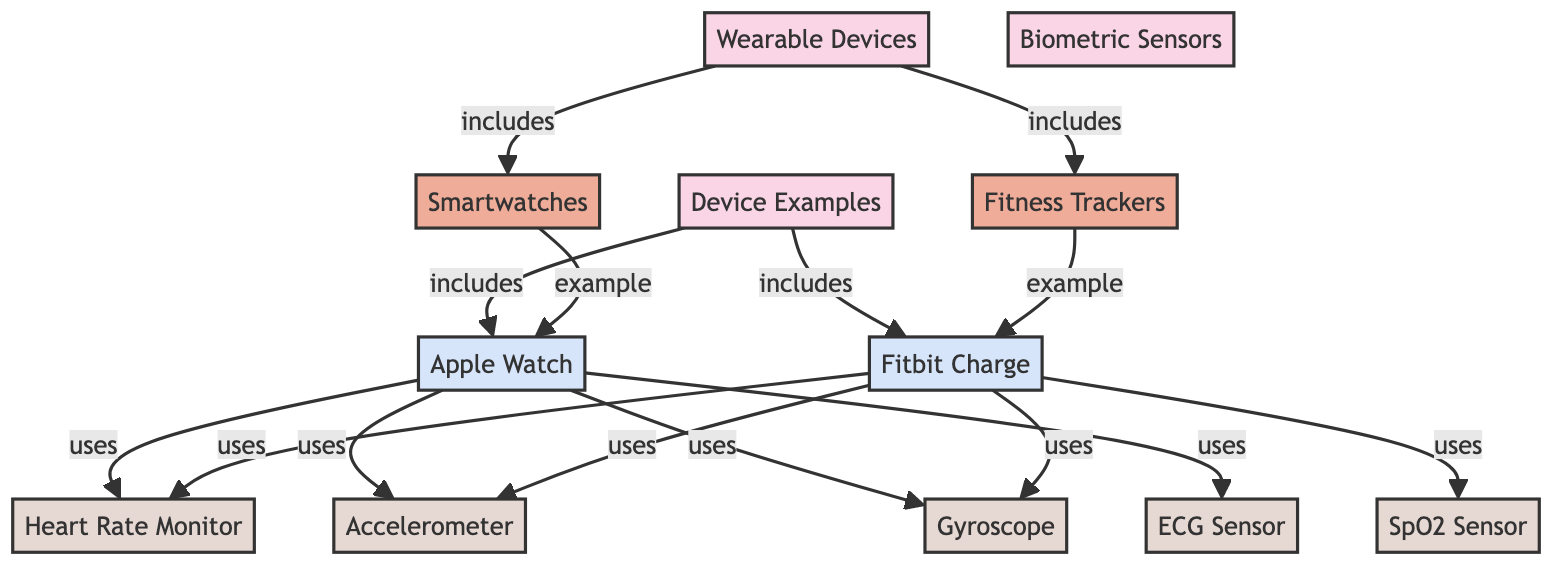What subcategories fall under wearable devices? The diagram shows that the subcategories of wearable devices include smartwatches and fitness trackers, which are directly connected to the main category of wearable devices.
Answer: smartwatches, fitness trackers Which device is an example of a smartwatch? The diagram illustrates that the Apple Watch is categorized as an example under the smartwatch subcategory, indicated by its direct connection to that node.
Answer: Apple Watch How many types of biometric sensors are represented in the diagram? By examining the biometric sensors section, we can see that there are five different types listed, including heart rate monitor, accelerometer, gyroscope, SpO2 sensor, and ECG sensor.
Answer: five What sensor is used by both Apple Watch and Fitbit Charge? Both devices use the heart rate monitor, which is linked to both the Apple Watch and Fitbit Charge nodes in the diagram, highlighting its commonality between these two devices.
Answer: heart rate monitor Which device utilizes the SpO2 sensor? The diagram shows that the Fitbit Charge is the only device listed that utilizes the SpO2 sensor, as it directly connects only to the Fitbit Charge node and not to the Apple Watch.
Answer: Fitbit Charge How many total sensors are listed in the diagram? The diagram outlines a total of five different sensors, signifying their presence in the biometric sensors category.
Answer: five What relationship exists between smartwatches and the sensors they use? Smartwatches are shown to use four different sensors: heart rate monitor, accelerometer, gyroscope, and ECG sensor, indicating a multiple connection between these categories.
Answer: uses Which wearable device uses the most sensors according to the diagram? Analyzing the connections, it becomes clear that the Apple Watch employs four sensors, while the Fitbit Charge employs three, making the Apple Watch the device that utilizes the most sensors.
Answer: Apple Watch What is the primary category of health devices represented in the diagram? The main category presented in the diagram that encompasses all related wearable devices and sensors is titled 'Wearable Devices', indicating its overarching classification.
Answer: Wearable Devices 